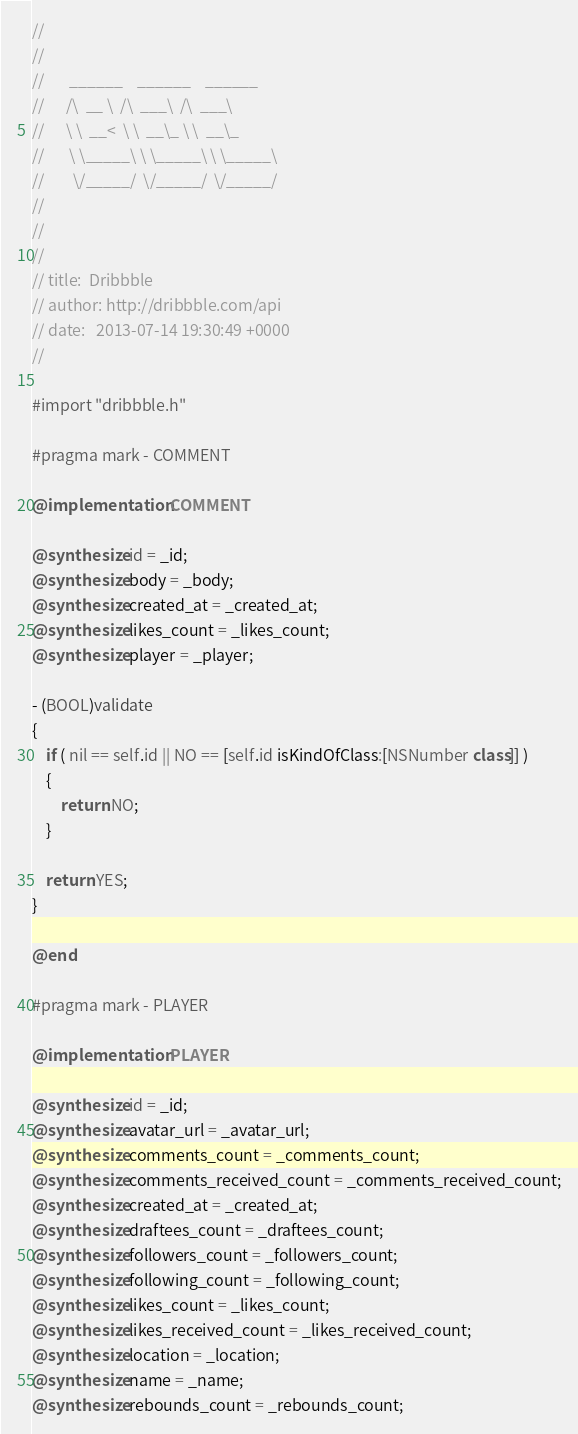Convert code to text. <code><loc_0><loc_0><loc_500><loc_500><_ObjectiveC_>//    												
//    												
//    	 ______    ______    ______					
//    	/\  __ \  /\  ___\  /\  ___\			
//    	\ \  __<  \ \  __\_ \ \  __\_		
//    	 \ \_____\ \ \_____\ \ \_____\		
//    	  \/_____/  \/_____/  \/_____/			
//    												
//    												
//    												
// title:  Dribbble
// author: http://dribbble.com/api
// date:   2013-07-14 19:30:49 +0000
//

#import "dribbble.h"

#pragma mark - COMMENT

@implementation COMMENT

@synthesize id = _id;
@synthesize body = _body;
@synthesize created_at = _created_at;
@synthesize likes_count = _likes_count;
@synthesize player = _player;

- (BOOL)validate
{
	if ( nil == self.id || NO == [self.id isKindOfClass:[NSNumber class]] )
	{
		return NO;
	}

	return YES;
}

@end

#pragma mark - PLAYER

@implementation PLAYER

@synthesize id = _id;
@synthesize avatar_url = _avatar_url;
@synthesize comments_count = _comments_count;
@synthesize comments_received_count = _comments_received_count;
@synthesize created_at = _created_at;
@synthesize draftees_count = _draftees_count;
@synthesize followers_count = _followers_count;
@synthesize following_count = _following_count;
@synthesize likes_count = _likes_count;
@synthesize likes_received_count = _likes_received_count;
@synthesize location = _location;
@synthesize name = _name;
@synthesize rebounds_count = _rebounds_count;</code> 